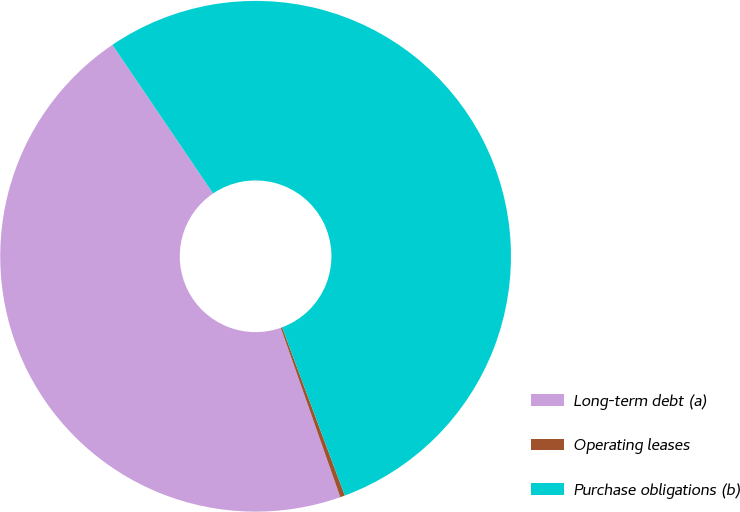<chart> <loc_0><loc_0><loc_500><loc_500><pie_chart><fcel>Long-term debt (a)<fcel>Operating leases<fcel>Purchase obligations (b)<nl><fcel>45.91%<fcel>0.3%<fcel>53.79%<nl></chart> 